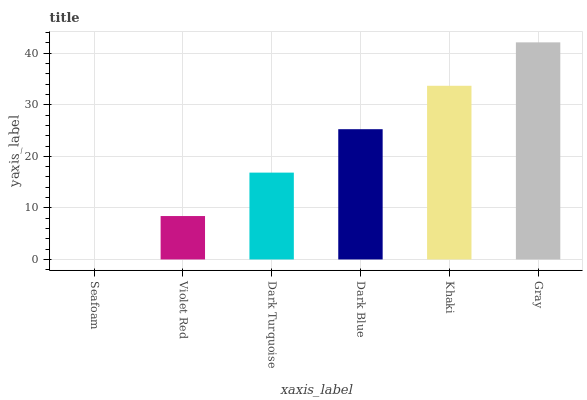Is Seafoam the minimum?
Answer yes or no. Yes. Is Gray the maximum?
Answer yes or no. Yes. Is Violet Red the minimum?
Answer yes or no. No. Is Violet Red the maximum?
Answer yes or no. No. Is Violet Red greater than Seafoam?
Answer yes or no. Yes. Is Seafoam less than Violet Red?
Answer yes or no. Yes. Is Seafoam greater than Violet Red?
Answer yes or no. No. Is Violet Red less than Seafoam?
Answer yes or no. No. Is Dark Blue the high median?
Answer yes or no. Yes. Is Dark Turquoise the low median?
Answer yes or no. Yes. Is Dark Turquoise the high median?
Answer yes or no. No. Is Violet Red the low median?
Answer yes or no. No. 